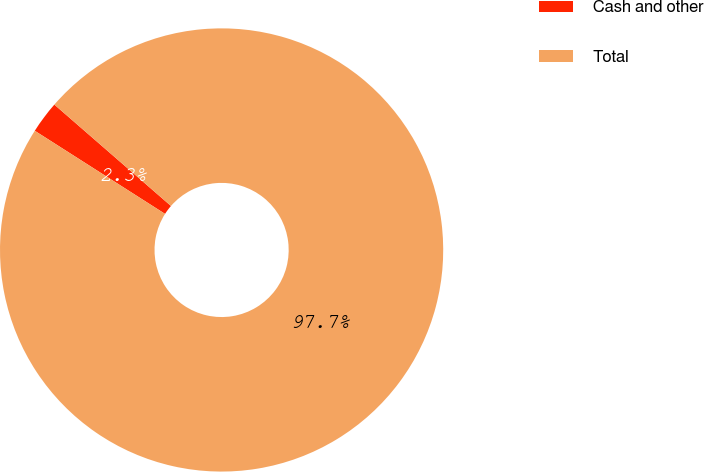Convert chart. <chart><loc_0><loc_0><loc_500><loc_500><pie_chart><fcel>Cash and other<fcel>Total<nl><fcel>2.35%<fcel>97.65%<nl></chart> 